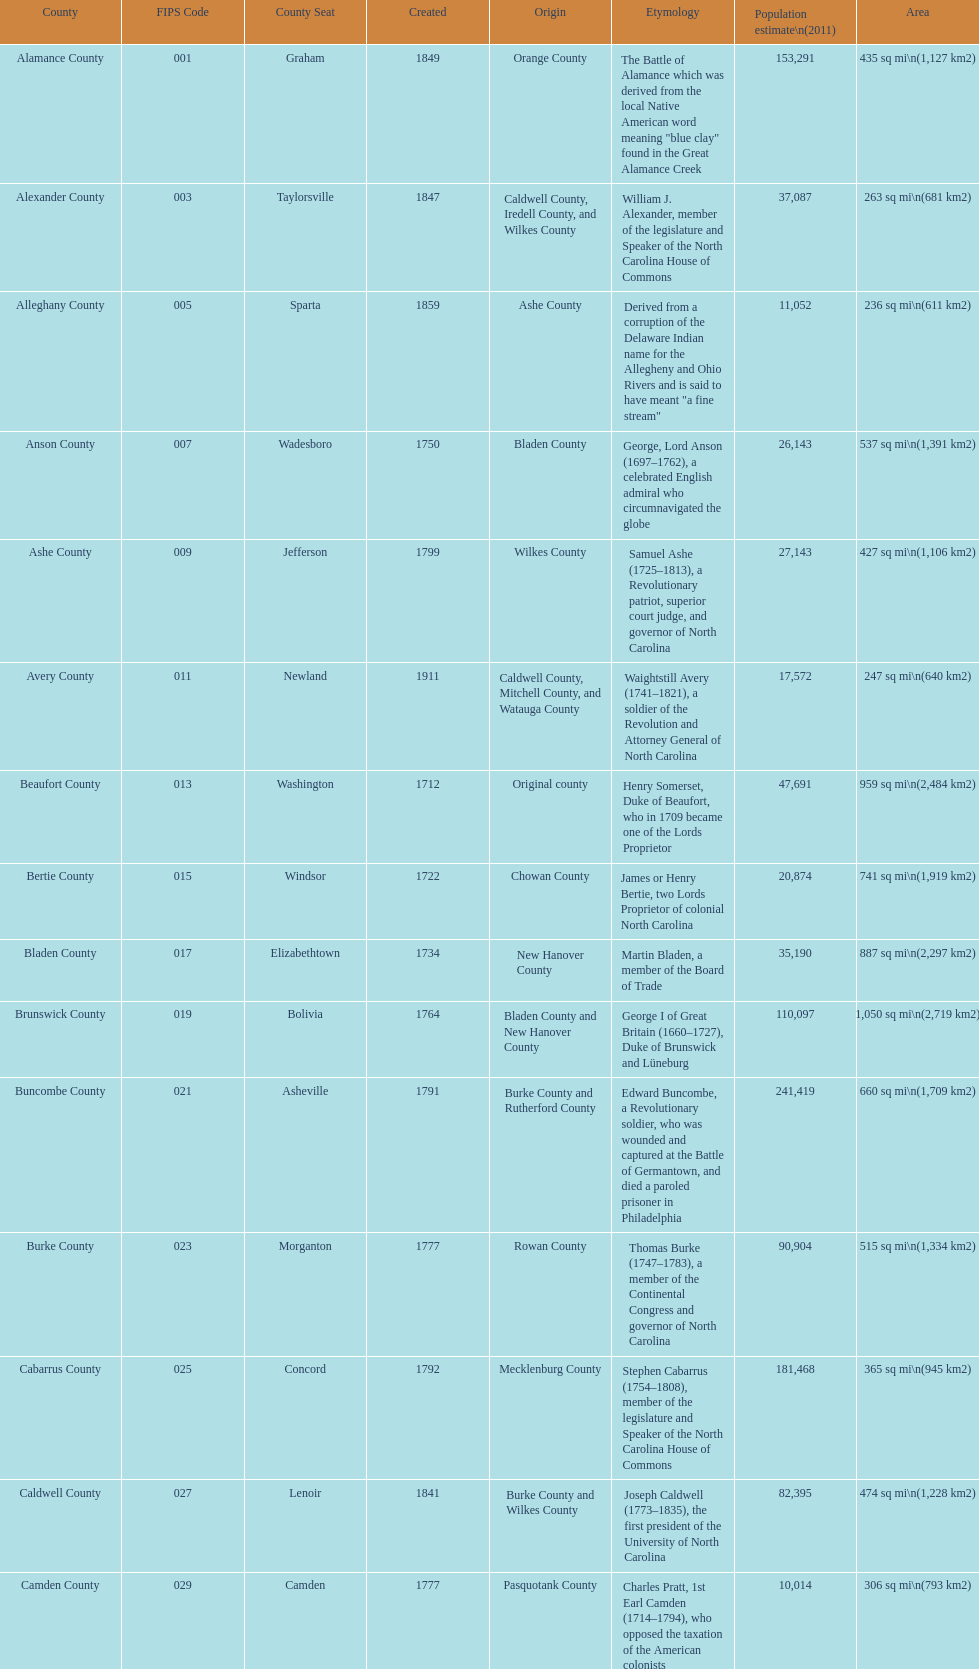Excluding mecklenburg, which county has the highest population? Wake County. 